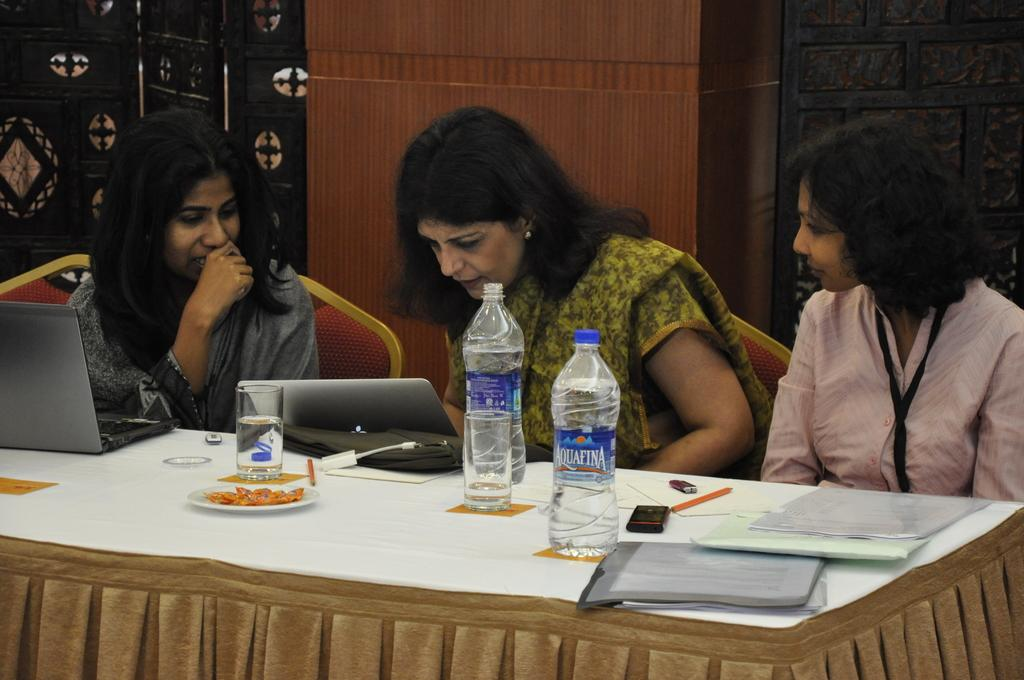How many women are in the image? There are three women in the image. What are the women doing in the image? The women are sitting on a table. What else can be seen on the table besides the women? There are books and water bottles on the table. Is there a tub filled with butter in the image? No, there is no tub or butter present in the image. 